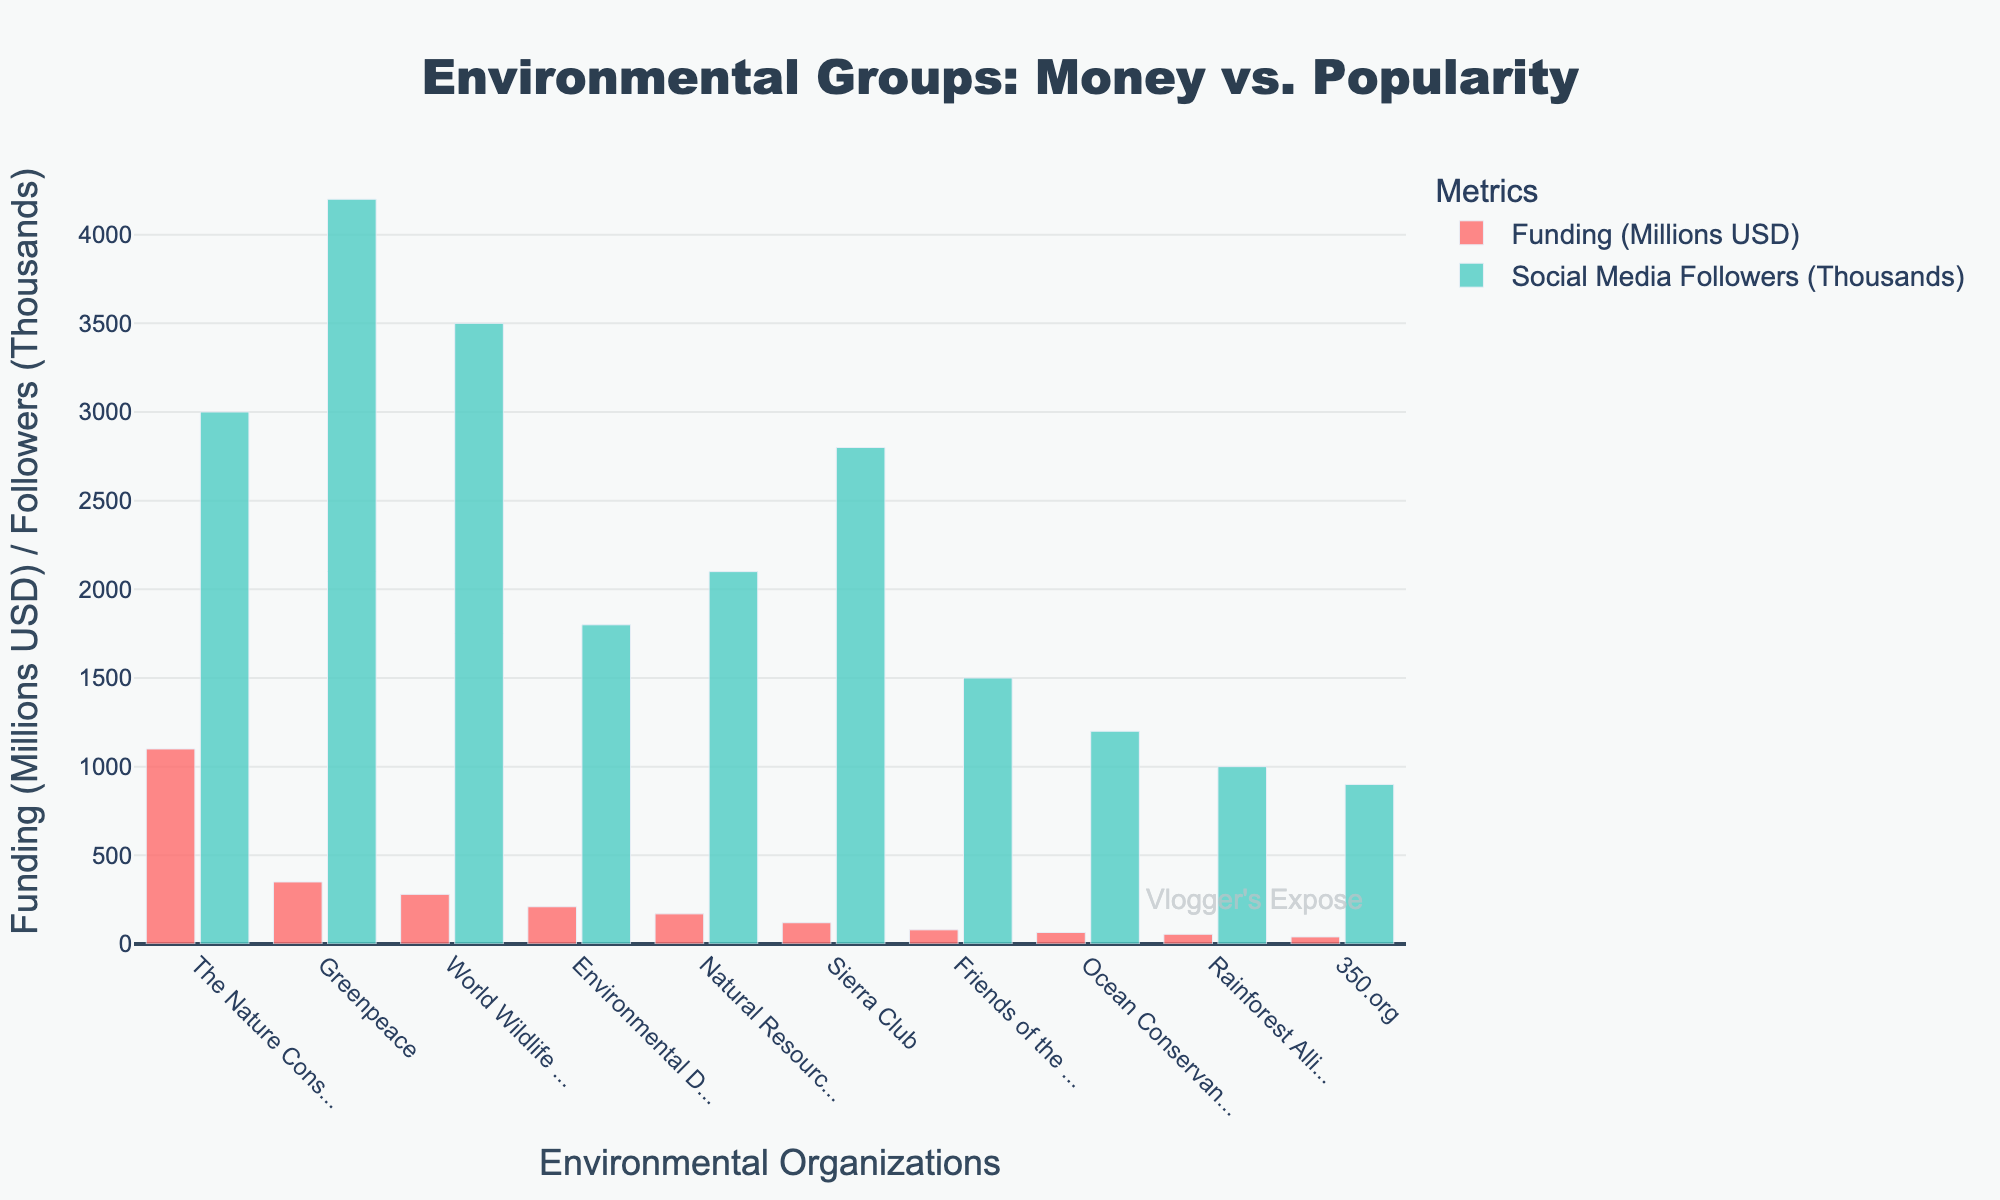Which organization has the most funding? The bar representing "The Nature Conservancy" is the highest and colored in red, indicating that it has the most funding.
Answer: The Nature Conservancy Which organization has the most social media followers? The bar representing "Greenpeace" is the highest and colored in green, indicating that it has the most social media followers.
Answer: Greenpeace What is the difference in funding between Greenpeace and Sierra Club? Greenpeace has 350 million USD, and Sierra Club has 120 million USD. The difference is 350 - 120 = 230 million USD.
Answer: 230 million USD Which organization has more followers: 350.org or Rainforest Alliance? The green bar for "Rainforest Alliance" is slightly higher than the green bar for "350.org," indicating that Rainforest Alliance has more social media followers.
Answer: Rainforest Alliance What is the total funding for Environmental Defense Fund and Friends of the Earth? Environmental Defense Fund has 210 million USD, and Friends of the Earth has 80 million USD. The total is 210 + 80 = 290 million USD.
Answer: 290 million USD Identify the organization with funding more than 500 million USD and the one with the lowest social media followers. "The Nature Conservancy" has funding more than 500 million USD, and "350.org" has the lowest social media followers at 900 thousand.
Answer: The Nature Conservancy, 350.org Calculate the average social media followers for Ocean Conservancy, Rainforest Alliance, and Friends of the Earth. Ocean Conservancy has 1200K, Rainforest Alliance has 1000K, and Friends of the Earth has 1500K followers. The average is (1200 + 1000 + 1500) / 3 = 1233.33K.
Answer: 1233.33K Which organization has higher funding: World Wildlife Fund or Natural Resources Defense Council? The red bar for "World Wildlife Fund" is higher than the red bar for "Natural Resources Defense Council," indicating that the World Wildlife Fund has higher funding.
Answer: World Wildlife Fund What's the total number of followers for the three organizations with the most social media followers? Greenpeace has 4200K, World Wildlife Fund has 3500K, and Sierra Club has 2800K followers. The total is 4200 + 3500 + 2800 = 10500K followers.
Answer: 10500K 